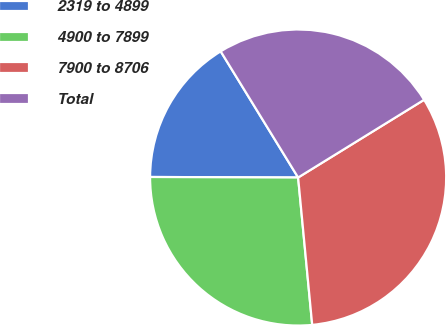Convert chart. <chart><loc_0><loc_0><loc_500><loc_500><pie_chart><fcel>2319 to 4899<fcel>4900 to 7899<fcel>7900 to 8706<fcel>Total<nl><fcel>16.18%<fcel>26.57%<fcel>32.28%<fcel>24.96%<nl></chart> 